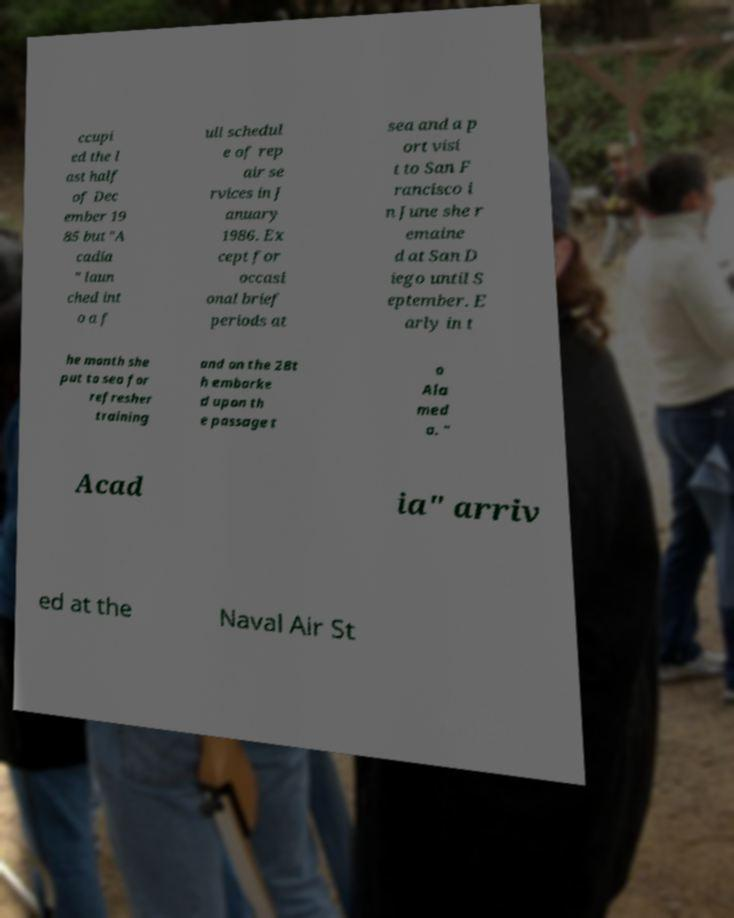Could you assist in decoding the text presented in this image and type it out clearly? ccupi ed the l ast half of Dec ember 19 85 but "A cadia " laun ched int o a f ull schedul e of rep air se rvices in J anuary 1986. Ex cept for occasi onal brief periods at sea and a p ort visi t to San F rancisco i n June she r emaine d at San D iego until S eptember. E arly in t he month she put to sea for refresher training and on the 28t h embarke d upon th e passage t o Ala med a. " Acad ia" arriv ed at the Naval Air St 